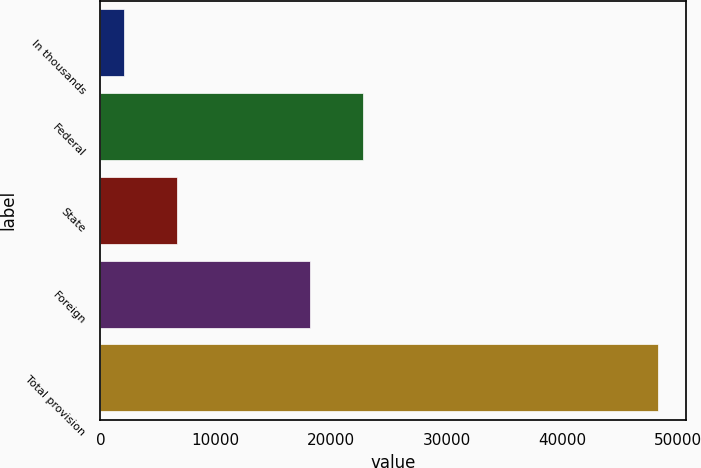Convert chart to OTSL. <chart><loc_0><loc_0><loc_500><loc_500><bar_chart><fcel>In thousands<fcel>Federal<fcel>State<fcel>Foreign<fcel>Total provision<nl><fcel>2009<fcel>22743.5<fcel>6638.5<fcel>18114<fcel>48304<nl></chart> 